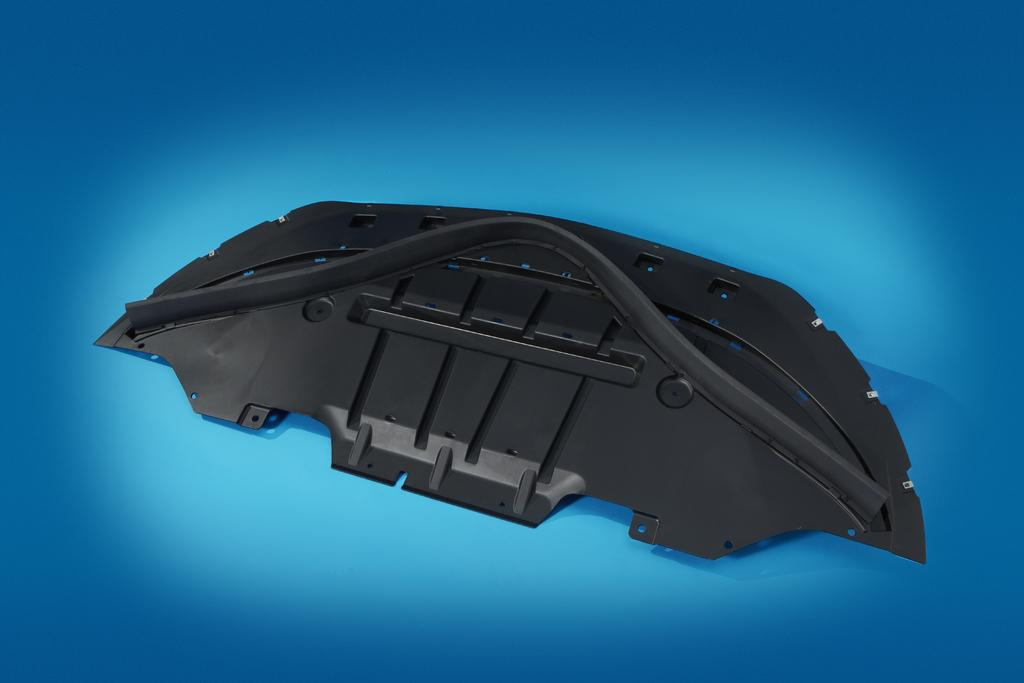What is the main object in the image? There is a black color plastic piece in the image. What color is the plastic piece? The plastic piece is black. What can be seen in the background of the image? The background of the image is blue. What type of vessel is being used to store the lip in the image? There is no vessel or lip present in the image; it only features a black color plastic piece. 